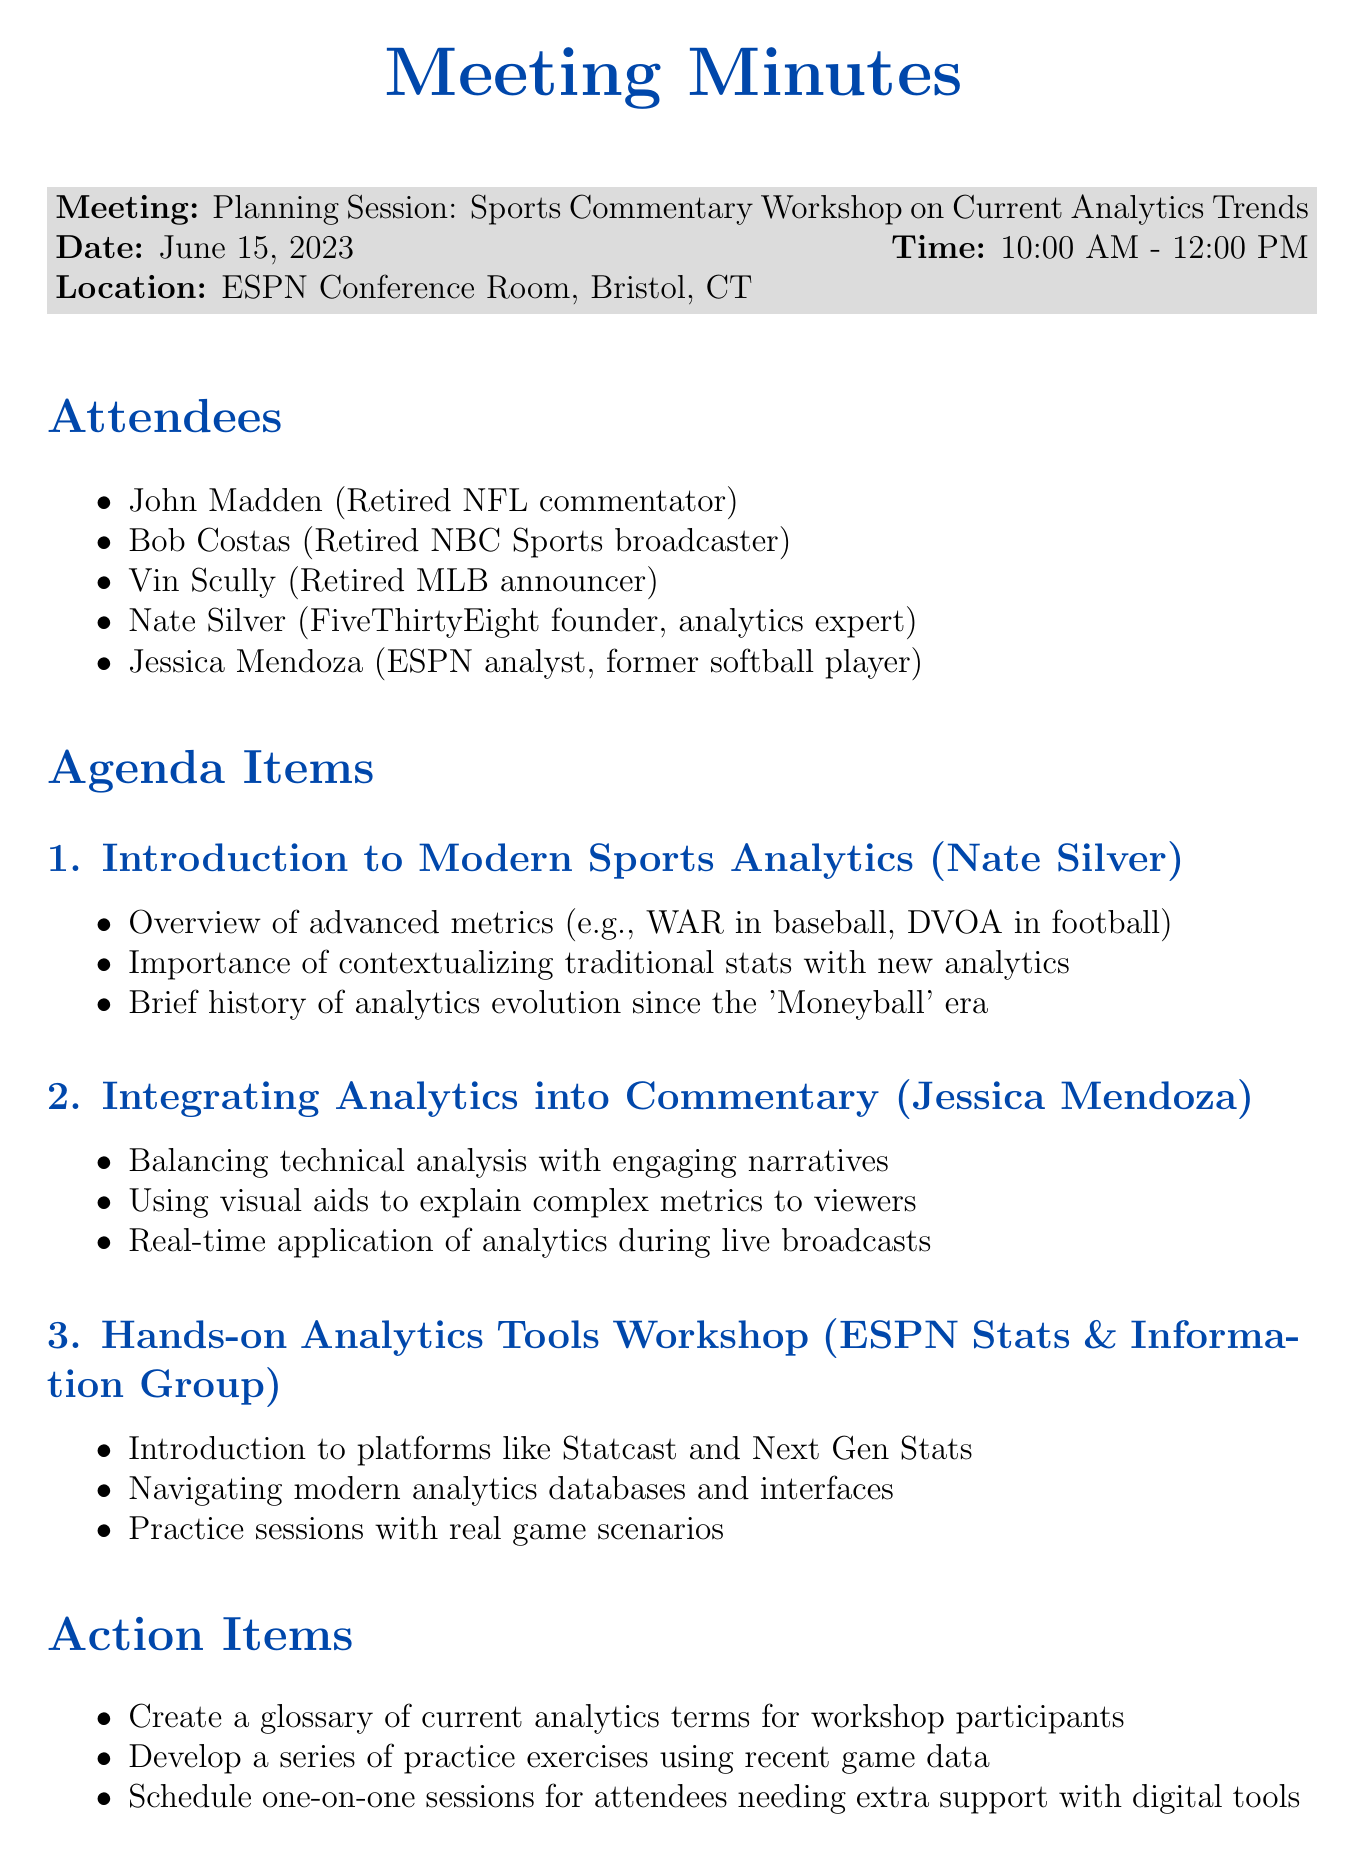What is the title of the meeting? The title of the meeting is mentioned at the beginning of the document.
Answer: Planning Session: Sports Commentary Workshop on Current Analytics Trends Who presented the topic on modern sports analytics? The document states that Nate Silver presented this topic.
Answer: Nate Silver What date was the meeting held? The date of the meeting is listed in the meeting details section.
Answer: June 15, 2023 How many attendees were present? The document lists five attendees in the attendees section.
Answer: Five What is one of the action items discussed? Action items are listed, and one example can be selected from there.
Answer: Create a glossary of current analytics terms for workshop participants Which platform was introduced during the hands-on workshop? The document specifically mentions a platform introduced during this section.
Answer: Statcast What is the purpose of the next steps section? The next steps itemizes actions to be taken after the meeting, reflecting future plans.
Answer: Finalize workshop date and venue Who is responsible for the hands-on analytics tools workshop? The document attributes this part of the agenda to a specific group.
Answer: ESPN Stats & Information Group What type of participants was the workshop aimed at? The document indicates the workshop is aimed at a particular group, which is stated in the purpose.
Answer: Retired professionals 